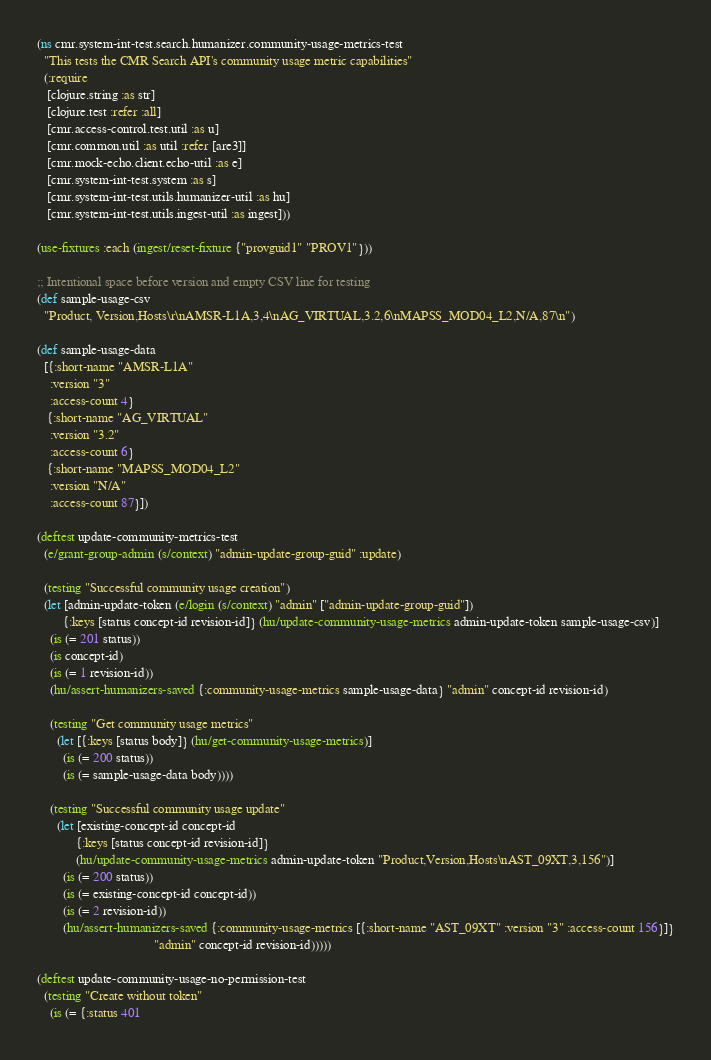<code> <loc_0><loc_0><loc_500><loc_500><_Clojure_>(ns cmr.system-int-test.search.humanizer.community-usage-metrics-test
  "This tests the CMR Search API's community usage metric capabilities"
  (:require
   [clojure.string :as str]
   [clojure.test :refer :all]
   [cmr.access-control.test.util :as u]
   [cmr.common.util :as util :refer [are3]]
   [cmr.mock-echo.client.echo-util :as e]
   [cmr.system-int-test.system :as s]
   [cmr.system-int-test.utils.humanizer-util :as hu]
   [cmr.system-int-test.utils.ingest-util :as ingest]))

(use-fixtures :each (ingest/reset-fixture {"provguid1" "PROV1"}))

;; Intentional space before version and empty CSV line for testing
(def sample-usage-csv
  "Product, Version,Hosts\r\nAMSR-L1A,3,4\nAG_VIRTUAL,3.2,6\nMAPSS_MOD04_L2,N/A,87\n")

(def sample-usage-data
  [{:short-name "AMSR-L1A"
    :version "3"
    :access-count 4}
   {:short-name "AG_VIRTUAL"
    :version "3.2"
    :access-count 6}
   {:short-name "MAPSS_MOD04_L2"
    :version "N/A"
    :access-count 87}])

(deftest update-community-metrics-test
  (e/grant-group-admin (s/context) "admin-update-group-guid" :update)

  (testing "Successful community usage creation")
  (let [admin-update-token (e/login (s/context) "admin" ["admin-update-group-guid"])
        {:keys [status concept-id revision-id]} (hu/update-community-usage-metrics admin-update-token sample-usage-csv)]
    (is (= 201 status))
    (is concept-id)
    (is (= 1 revision-id))
    (hu/assert-humanizers-saved {:community-usage-metrics sample-usage-data} "admin" concept-id revision-id)

    (testing "Get community usage metrics"
      (let [{:keys [status body]} (hu/get-community-usage-metrics)]
        (is (= 200 status))
        (is (= sample-usage-data body))))

    (testing "Successful community usage update"
      (let [existing-concept-id concept-id
            {:keys [status concept-id revision-id]}
            (hu/update-community-usage-metrics admin-update-token "Product,Version,Hosts\nAST_09XT,3,156")]
        (is (= 200 status))
        (is (= existing-concept-id concept-id))
        (is (= 2 revision-id))
        (hu/assert-humanizers-saved {:community-usage-metrics [{:short-name "AST_09XT" :version "3" :access-count 156}]}
                                    "admin" concept-id revision-id)))))

(deftest update-community-usage-no-permission-test
  (testing "Create without token"
    (is (= {:status 401</code> 